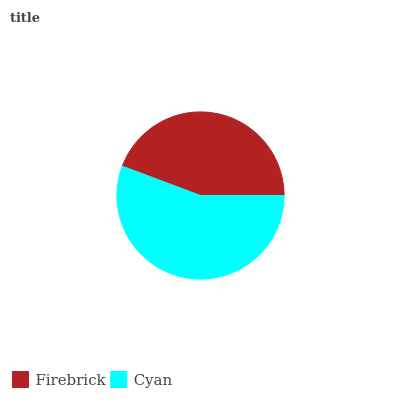Is Firebrick the minimum?
Answer yes or no. Yes. Is Cyan the maximum?
Answer yes or no. Yes. Is Cyan the minimum?
Answer yes or no. No. Is Cyan greater than Firebrick?
Answer yes or no. Yes. Is Firebrick less than Cyan?
Answer yes or no. Yes. Is Firebrick greater than Cyan?
Answer yes or no. No. Is Cyan less than Firebrick?
Answer yes or no. No. Is Cyan the high median?
Answer yes or no. Yes. Is Firebrick the low median?
Answer yes or no. Yes. Is Firebrick the high median?
Answer yes or no. No. Is Cyan the low median?
Answer yes or no. No. 